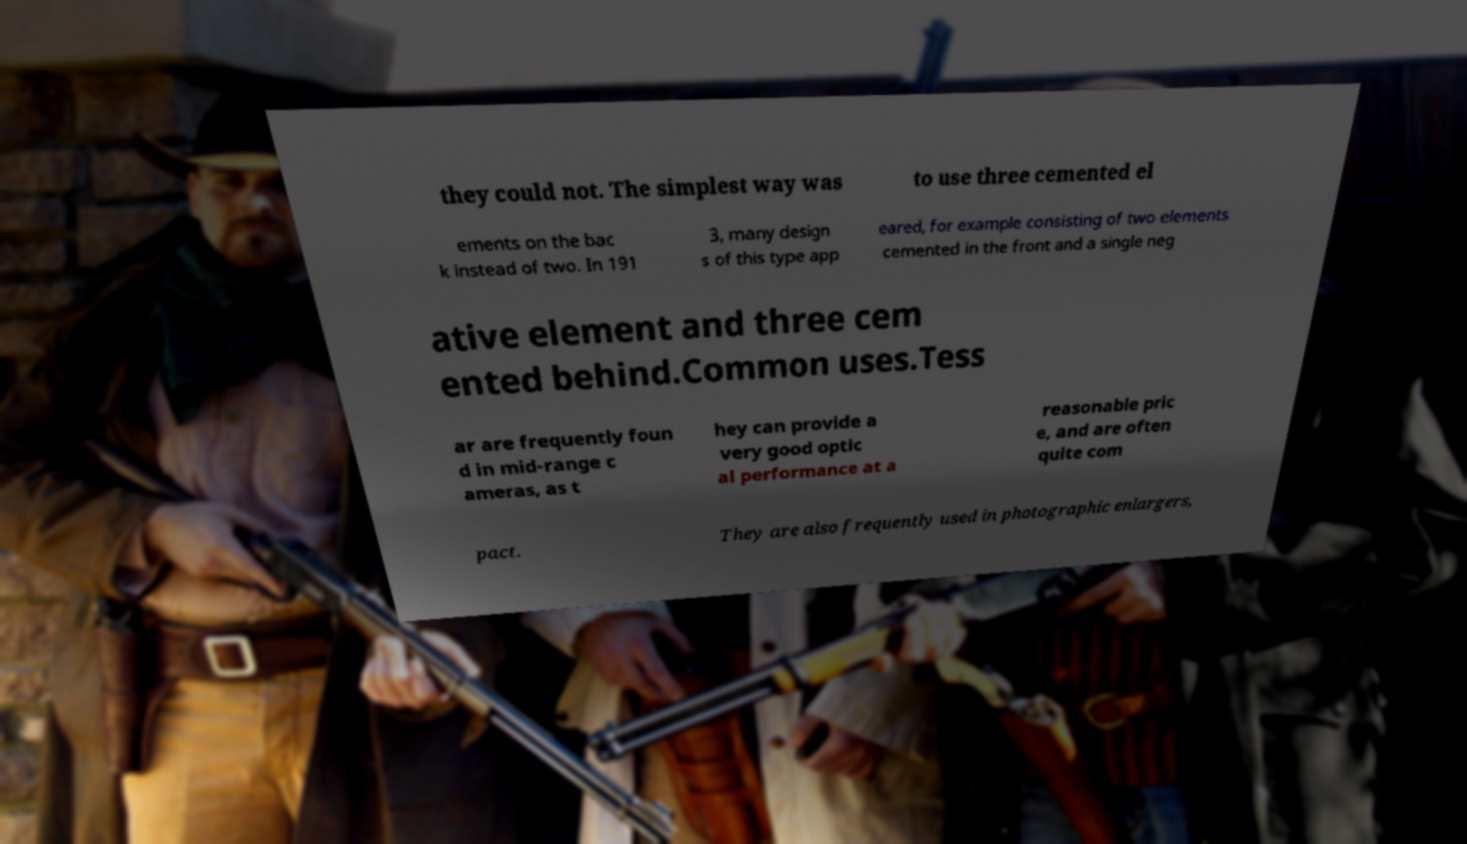What messages or text are displayed in this image? I need them in a readable, typed format. they could not. The simplest way was to use three cemented el ements on the bac k instead of two. In 191 3, many design s of this type app eared, for example consisting of two elements cemented in the front and a single neg ative element and three cem ented behind.Common uses.Tess ar are frequently foun d in mid-range c ameras, as t hey can provide a very good optic al performance at a reasonable pric e, and are often quite com pact. They are also frequently used in photographic enlargers, 